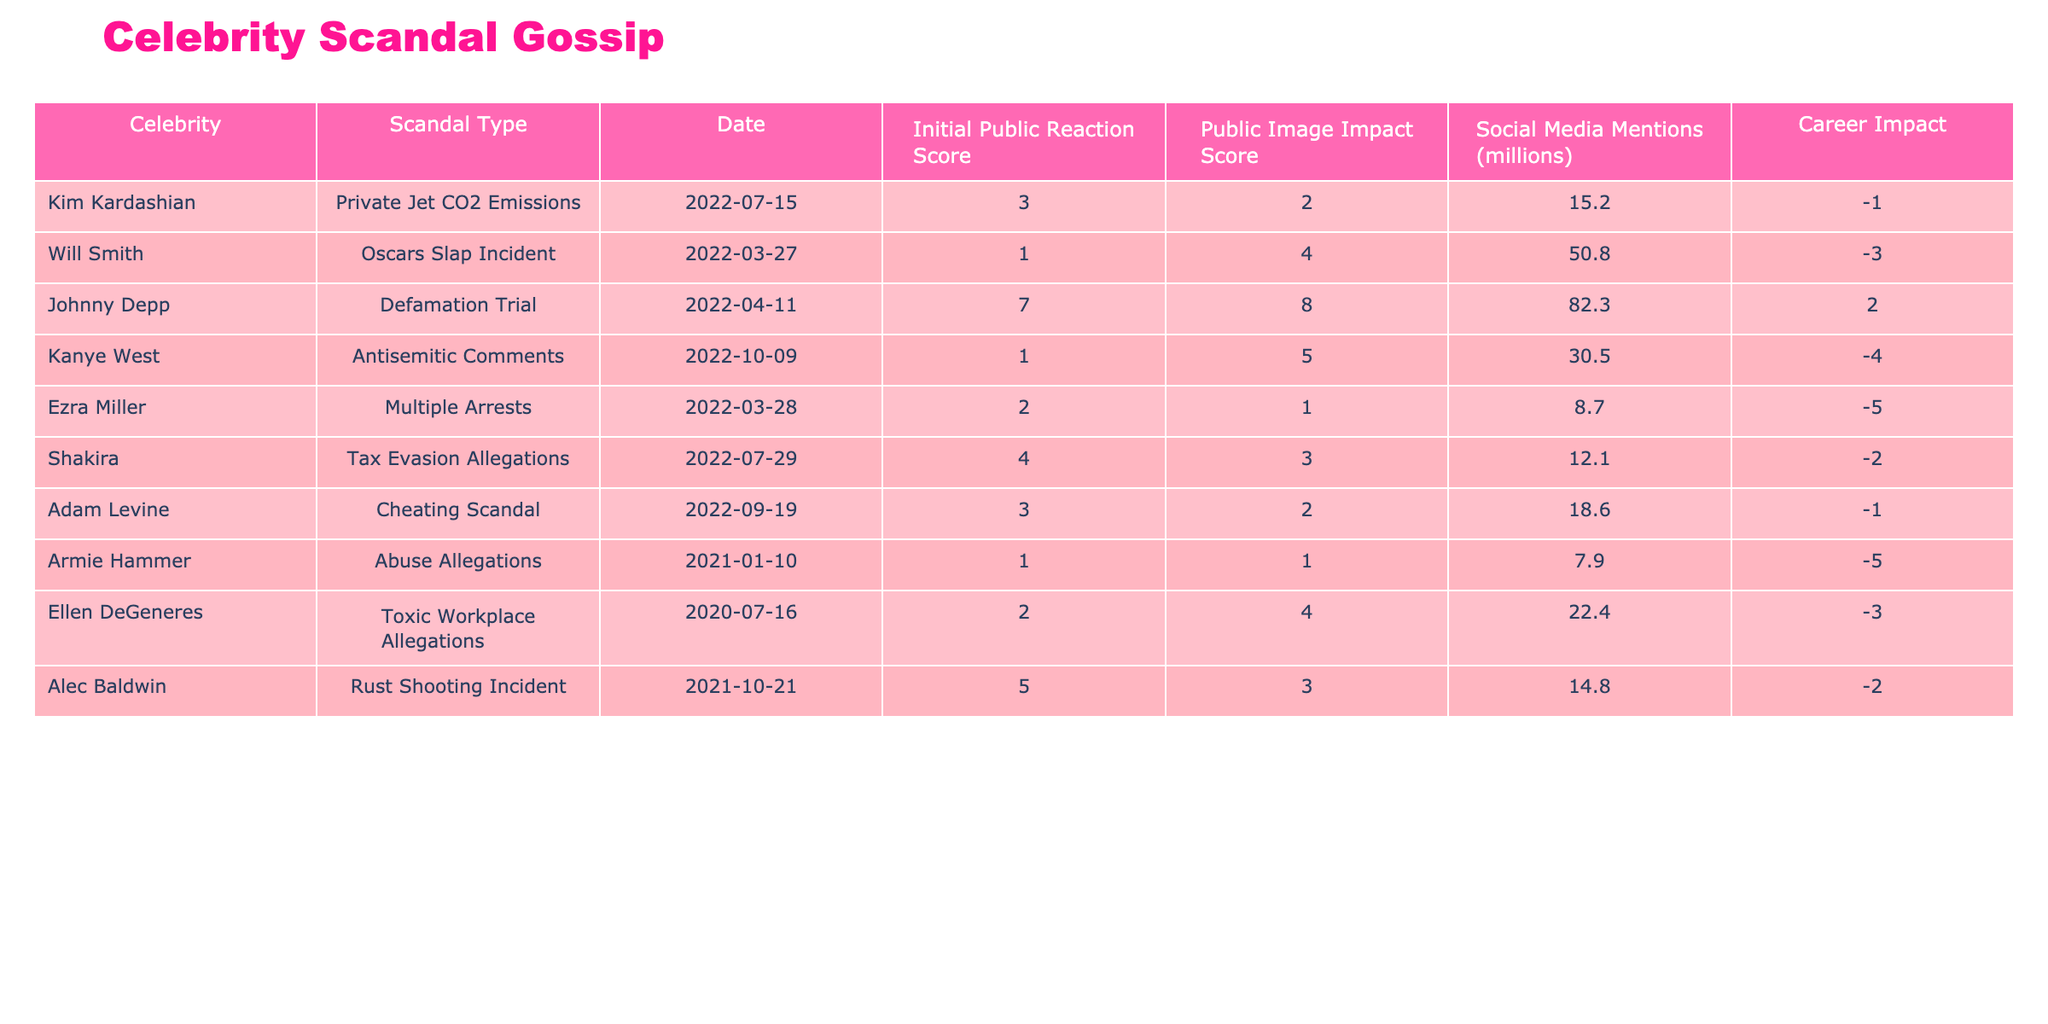What was the public's initial reaction score to Kanye West's scandal? Referring to the table, Kanye West's initial public reaction score is listed as 1.
Answer: 1 Which scandal had the highest public image impact score? By examining the public image impact scores in the table, Johnny Depp's defamation trial has the highest score of 8.
Answer: 8 How many social media mentions did Will Smith's incident receive? According to the table, Will Smith's Oscars slap incident received 50.8 million social media mentions.
Answer: 50.8 Can we say that Armie Hammer had a positive career impact after his scandal? Looking at the table, Armie Hammer's career impact score is -5, indicating a negative impact on his career.
Answer: No What is the average initial public reaction score for the scandals listed? The initial public reaction scores are 3, 1, 7, 1, 2, 4, 3, 1, 2, and 5 (10 scores total). Their sum is 30. Dividing by 10 gives an average of 3.
Answer: 3 Did any scandal result in a positive career impact? Evaluating the career impact scores, the only positive score is 2 for Johnny Depp, indicating a positive impact.
Answer: Yes What is the difference in social media mentions between Kim Kardashian's and Shakira's scandals? Kim Kardashian has 15.2 million social media mentions, and Shakira has 12.1 million. The difference is 15.2 - 12.1 = 3.1 million mentions.
Answer: 3.1 How many celebrities faced scandals with a public image impact score of 3 or higher? The table shows the following public image impact scores: 2, 4, 3, 5, 8, 4, 3. Counting those with scores of 3 or higher gives 5 celebrities (Will Smith, Johnny Depp, Kanye West, Ellen DeGeneres, and Shakira).
Answer: 5 Which celebrity had the least negative impact on their career? Looking at the career impact scores, Johnny Depp has a score of 2, which is the least negative compared to others who have -1, -2, -3, -4, -5.
Answer: Johnny Depp What is the total number of social media mentions for all scandals combined? The social media mentions are 15.2, 50.8, 82.3, 30.5, 8.7, 12.1, 18.6, 7.9, 22.4, and 14.8. Adding these gives a total of 307.9 million mentions.
Answer: 307.9 